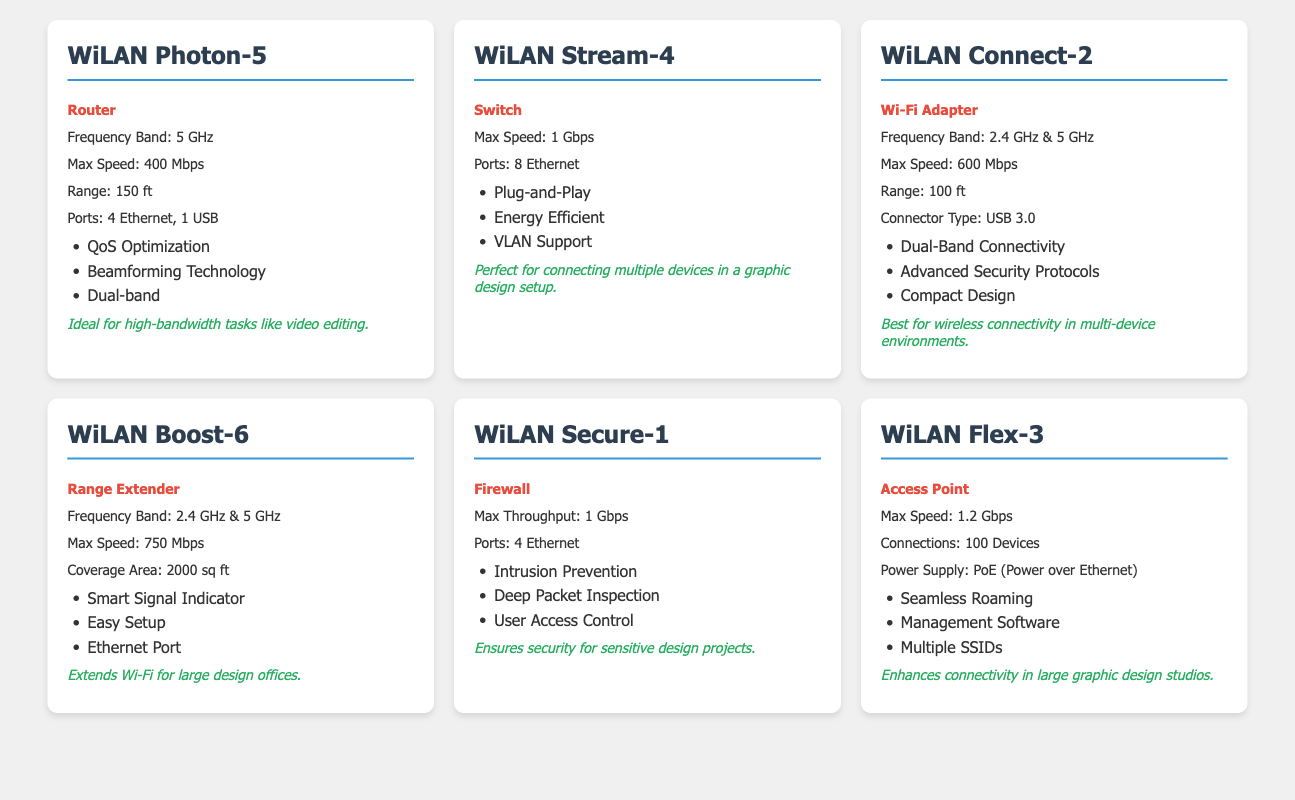What is the maximum speed of the WiLAN Boost-6? The table shows that the maximum speed for WiLAN Boost-6 is listed as 750 Mbps.
Answer: 750 Mbps Which product has the highest maximum speed? By examining the table, we see that WiLAN Flex-3 has the highest maximum speed at 1.2 Gbps, compared to others like WiLAN Stream-4 at 1 Gbps and WiLAN Boost-6 at 750 Mbps.
Answer: WiLAN Flex-3 Is the WiLAN Secure-1 a router? The table categorizes WiLAN Secure-1 as a Firewall, not as a router.
Answer: No How many ports does the WiLAN Stream-4 have? The table indicates that WiLAN Stream-4 has 8 Ethernet ports listed under its specifications.
Answer: 8 Ethernet Which products support dual-band connectivity? The table reveals that WiLAN Photon-5, WiLAN Connect-2, and WiLAN Boost-6 support dual-band connectivity, based on the specifications provided for frequency bands.
Answer: WiLAN Photon-5, WiLAN Connect-2, WiLAN Boost-6 What is the range of WiLAN Connect-2? The specifications in the table state that the range of WiLAN Connect-2 is 100 ft.
Answer: 100 ft If you combine the maximum speeds of WiLAN Stream-4 and WiLAN Secure-1, what do you get? The maximum speed for WiLAN Stream-4 is 1 Gbps and for WiLAN Secure-1 is also 1 Gbps. Adding them together gives us 1 + 1 = 2 Gbps.
Answer: 2 Gbps Which product is ideal for security in design projects? The table specifies that WiLAN Secure-1 ensures security for sensitive design projects, therefore making it the ideal choice for this purpose.
Answer: WiLAN Secure-1 What is the total number of devices that can connect to WiLAN Flex-3? According to the table, WiLAN Flex-3 can support connections for up to 100 devices, as explicitly mentioned in its specifications.
Answer: 100 devices 